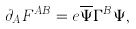Convert formula to latex. <formula><loc_0><loc_0><loc_500><loc_500>\partial _ { A } F ^ { A B } = e \overline { \Psi } \Gamma ^ { B } \Psi ,</formula> 